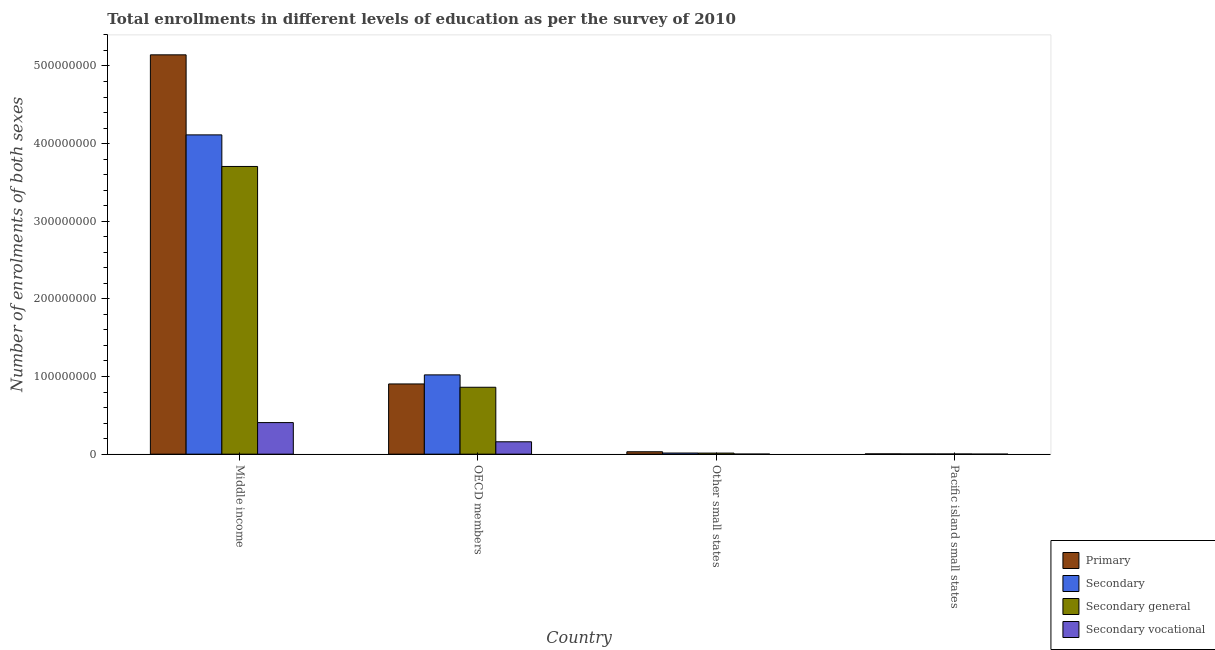How many different coloured bars are there?
Make the answer very short. 4. Are the number of bars on each tick of the X-axis equal?
Offer a very short reply. Yes. How many bars are there on the 2nd tick from the left?
Give a very brief answer. 4. What is the number of enrolments in primary education in Pacific island small states?
Provide a short and direct response. 3.53e+05. Across all countries, what is the maximum number of enrolments in secondary vocational education?
Your answer should be compact. 4.07e+07. Across all countries, what is the minimum number of enrolments in secondary vocational education?
Offer a very short reply. 5214.71. In which country was the number of enrolments in secondary vocational education minimum?
Make the answer very short. Pacific island small states. What is the total number of enrolments in primary education in the graph?
Provide a short and direct response. 6.08e+08. What is the difference between the number of enrolments in secondary general education in OECD members and that in Other small states?
Provide a succinct answer. 8.48e+07. What is the difference between the number of enrolments in secondary vocational education in Pacific island small states and the number of enrolments in primary education in Other small states?
Offer a very short reply. -3.08e+06. What is the average number of enrolments in secondary education per country?
Provide a succinct answer. 1.29e+08. What is the difference between the number of enrolments in secondary vocational education and number of enrolments in secondary general education in Other small states?
Offer a terse response. -1.31e+06. What is the ratio of the number of enrolments in secondary vocational education in OECD members to that in Other small states?
Ensure brevity in your answer.  196.79. Is the difference between the number of enrolments in primary education in Middle income and Other small states greater than the difference between the number of enrolments in secondary general education in Middle income and Other small states?
Your answer should be compact. Yes. What is the difference between the highest and the second highest number of enrolments in secondary general education?
Provide a succinct answer. 2.84e+08. What is the difference between the highest and the lowest number of enrolments in secondary vocational education?
Your answer should be very brief. 4.07e+07. In how many countries, is the number of enrolments in secondary education greater than the average number of enrolments in secondary education taken over all countries?
Provide a short and direct response. 1. Is the sum of the number of enrolments in secondary education in OECD members and Other small states greater than the maximum number of enrolments in secondary vocational education across all countries?
Your answer should be very brief. Yes. Is it the case that in every country, the sum of the number of enrolments in secondary vocational education and number of enrolments in primary education is greater than the sum of number of enrolments in secondary general education and number of enrolments in secondary education?
Your response must be concise. No. What does the 3rd bar from the left in OECD members represents?
Make the answer very short. Secondary general. What does the 3rd bar from the right in OECD members represents?
Give a very brief answer. Secondary. How many bars are there?
Offer a terse response. 16. Are all the bars in the graph horizontal?
Provide a short and direct response. No. How many countries are there in the graph?
Your answer should be compact. 4. Are the values on the major ticks of Y-axis written in scientific E-notation?
Give a very brief answer. No. Does the graph contain any zero values?
Offer a terse response. No. Where does the legend appear in the graph?
Provide a short and direct response. Bottom right. How many legend labels are there?
Provide a succinct answer. 4. What is the title of the graph?
Your answer should be very brief. Total enrollments in different levels of education as per the survey of 2010. Does "Water" appear as one of the legend labels in the graph?
Provide a short and direct response. No. What is the label or title of the Y-axis?
Offer a terse response. Number of enrolments of both sexes. What is the Number of enrolments of both sexes in Primary in Middle income?
Make the answer very short. 5.14e+08. What is the Number of enrolments of both sexes in Secondary in Middle income?
Provide a succinct answer. 4.11e+08. What is the Number of enrolments of both sexes in Secondary general in Middle income?
Your response must be concise. 3.71e+08. What is the Number of enrolments of both sexes of Secondary vocational in Middle income?
Provide a short and direct response. 4.07e+07. What is the Number of enrolments of both sexes of Primary in OECD members?
Provide a succinct answer. 9.04e+07. What is the Number of enrolments of both sexes of Secondary in OECD members?
Ensure brevity in your answer.  1.02e+08. What is the Number of enrolments of both sexes of Secondary general in OECD members?
Offer a very short reply. 8.62e+07. What is the Number of enrolments of both sexes in Secondary vocational in OECD members?
Offer a very short reply. 1.59e+07. What is the Number of enrolments of both sexes in Primary in Other small states?
Your response must be concise. 3.09e+06. What is the Number of enrolments of both sexes in Secondary in Other small states?
Your response must be concise. 1.47e+06. What is the Number of enrolments of both sexes of Secondary general in Other small states?
Offer a very short reply. 1.39e+06. What is the Number of enrolments of both sexes in Secondary vocational in Other small states?
Provide a succinct answer. 8.10e+04. What is the Number of enrolments of both sexes in Primary in Pacific island small states?
Keep it short and to the point. 3.53e+05. What is the Number of enrolments of both sexes of Secondary in Pacific island small states?
Give a very brief answer. 2.35e+05. What is the Number of enrolments of both sexes of Secondary general in Pacific island small states?
Ensure brevity in your answer.  2.30e+05. What is the Number of enrolments of both sexes in Secondary vocational in Pacific island small states?
Provide a succinct answer. 5214.71. Across all countries, what is the maximum Number of enrolments of both sexes in Primary?
Your response must be concise. 5.14e+08. Across all countries, what is the maximum Number of enrolments of both sexes of Secondary?
Provide a short and direct response. 4.11e+08. Across all countries, what is the maximum Number of enrolments of both sexes in Secondary general?
Ensure brevity in your answer.  3.71e+08. Across all countries, what is the maximum Number of enrolments of both sexes in Secondary vocational?
Your response must be concise. 4.07e+07. Across all countries, what is the minimum Number of enrolments of both sexes of Primary?
Ensure brevity in your answer.  3.53e+05. Across all countries, what is the minimum Number of enrolments of both sexes of Secondary?
Provide a short and direct response. 2.35e+05. Across all countries, what is the minimum Number of enrolments of both sexes of Secondary general?
Ensure brevity in your answer.  2.30e+05. Across all countries, what is the minimum Number of enrolments of both sexes of Secondary vocational?
Provide a succinct answer. 5214.71. What is the total Number of enrolments of both sexes in Primary in the graph?
Ensure brevity in your answer.  6.08e+08. What is the total Number of enrolments of both sexes in Secondary in the graph?
Keep it short and to the point. 5.15e+08. What is the total Number of enrolments of both sexes of Secondary general in the graph?
Offer a very short reply. 4.58e+08. What is the total Number of enrolments of both sexes in Secondary vocational in the graph?
Offer a very short reply. 5.67e+07. What is the difference between the Number of enrolments of both sexes in Primary in Middle income and that in OECD members?
Offer a terse response. 4.24e+08. What is the difference between the Number of enrolments of both sexes of Secondary in Middle income and that in OECD members?
Offer a terse response. 3.09e+08. What is the difference between the Number of enrolments of both sexes in Secondary general in Middle income and that in OECD members?
Your answer should be compact. 2.84e+08. What is the difference between the Number of enrolments of both sexes of Secondary vocational in Middle income and that in OECD members?
Give a very brief answer. 2.47e+07. What is the difference between the Number of enrolments of both sexes in Primary in Middle income and that in Other small states?
Offer a terse response. 5.11e+08. What is the difference between the Number of enrolments of both sexes in Secondary in Middle income and that in Other small states?
Your answer should be compact. 4.10e+08. What is the difference between the Number of enrolments of both sexes in Secondary general in Middle income and that in Other small states?
Offer a very short reply. 3.69e+08. What is the difference between the Number of enrolments of both sexes of Secondary vocational in Middle income and that in Other small states?
Your response must be concise. 4.06e+07. What is the difference between the Number of enrolments of both sexes of Primary in Middle income and that in Pacific island small states?
Your response must be concise. 5.14e+08. What is the difference between the Number of enrolments of both sexes in Secondary in Middle income and that in Pacific island small states?
Offer a terse response. 4.11e+08. What is the difference between the Number of enrolments of both sexes in Secondary general in Middle income and that in Pacific island small states?
Give a very brief answer. 3.70e+08. What is the difference between the Number of enrolments of both sexes of Secondary vocational in Middle income and that in Pacific island small states?
Keep it short and to the point. 4.07e+07. What is the difference between the Number of enrolments of both sexes of Primary in OECD members and that in Other small states?
Your response must be concise. 8.74e+07. What is the difference between the Number of enrolments of both sexes of Secondary in OECD members and that in Other small states?
Ensure brevity in your answer.  1.01e+08. What is the difference between the Number of enrolments of both sexes of Secondary general in OECD members and that in Other small states?
Your answer should be very brief. 8.48e+07. What is the difference between the Number of enrolments of both sexes of Secondary vocational in OECD members and that in Other small states?
Make the answer very short. 1.59e+07. What is the difference between the Number of enrolments of both sexes of Primary in OECD members and that in Pacific island small states?
Make the answer very short. 9.01e+07. What is the difference between the Number of enrolments of both sexes of Secondary in OECD members and that in Pacific island small states?
Provide a succinct answer. 1.02e+08. What is the difference between the Number of enrolments of both sexes of Secondary general in OECD members and that in Pacific island small states?
Ensure brevity in your answer.  8.59e+07. What is the difference between the Number of enrolments of both sexes of Secondary vocational in OECD members and that in Pacific island small states?
Keep it short and to the point. 1.59e+07. What is the difference between the Number of enrolments of both sexes in Primary in Other small states and that in Pacific island small states?
Ensure brevity in your answer.  2.74e+06. What is the difference between the Number of enrolments of both sexes in Secondary in Other small states and that in Pacific island small states?
Your answer should be compact. 1.23e+06. What is the difference between the Number of enrolments of both sexes of Secondary general in Other small states and that in Pacific island small states?
Your answer should be very brief. 1.16e+06. What is the difference between the Number of enrolments of both sexes in Secondary vocational in Other small states and that in Pacific island small states?
Ensure brevity in your answer.  7.58e+04. What is the difference between the Number of enrolments of both sexes of Primary in Middle income and the Number of enrolments of both sexes of Secondary in OECD members?
Your answer should be compact. 4.12e+08. What is the difference between the Number of enrolments of both sexes of Primary in Middle income and the Number of enrolments of both sexes of Secondary general in OECD members?
Your answer should be compact. 4.28e+08. What is the difference between the Number of enrolments of both sexes in Primary in Middle income and the Number of enrolments of both sexes in Secondary vocational in OECD members?
Give a very brief answer. 4.98e+08. What is the difference between the Number of enrolments of both sexes of Secondary in Middle income and the Number of enrolments of both sexes of Secondary general in OECD members?
Your response must be concise. 3.25e+08. What is the difference between the Number of enrolments of both sexes of Secondary in Middle income and the Number of enrolments of both sexes of Secondary vocational in OECD members?
Offer a very short reply. 3.95e+08. What is the difference between the Number of enrolments of both sexes of Secondary general in Middle income and the Number of enrolments of both sexes of Secondary vocational in OECD members?
Your response must be concise. 3.55e+08. What is the difference between the Number of enrolments of both sexes of Primary in Middle income and the Number of enrolments of both sexes of Secondary in Other small states?
Your answer should be very brief. 5.13e+08. What is the difference between the Number of enrolments of both sexes in Primary in Middle income and the Number of enrolments of both sexes in Secondary general in Other small states?
Provide a succinct answer. 5.13e+08. What is the difference between the Number of enrolments of both sexes in Primary in Middle income and the Number of enrolments of both sexes in Secondary vocational in Other small states?
Make the answer very short. 5.14e+08. What is the difference between the Number of enrolments of both sexes of Secondary in Middle income and the Number of enrolments of both sexes of Secondary general in Other small states?
Your response must be concise. 4.10e+08. What is the difference between the Number of enrolments of both sexes of Secondary in Middle income and the Number of enrolments of both sexes of Secondary vocational in Other small states?
Offer a very short reply. 4.11e+08. What is the difference between the Number of enrolments of both sexes of Secondary general in Middle income and the Number of enrolments of both sexes of Secondary vocational in Other small states?
Give a very brief answer. 3.70e+08. What is the difference between the Number of enrolments of both sexes in Primary in Middle income and the Number of enrolments of both sexes in Secondary in Pacific island small states?
Your response must be concise. 5.14e+08. What is the difference between the Number of enrolments of both sexes of Primary in Middle income and the Number of enrolments of both sexes of Secondary general in Pacific island small states?
Ensure brevity in your answer.  5.14e+08. What is the difference between the Number of enrolments of both sexes in Primary in Middle income and the Number of enrolments of both sexes in Secondary vocational in Pacific island small states?
Give a very brief answer. 5.14e+08. What is the difference between the Number of enrolments of both sexes in Secondary in Middle income and the Number of enrolments of both sexes in Secondary general in Pacific island small states?
Offer a terse response. 4.11e+08. What is the difference between the Number of enrolments of both sexes of Secondary in Middle income and the Number of enrolments of both sexes of Secondary vocational in Pacific island small states?
Your answer should be very brief. 4.11e+08. What is the difference between the Number of enrolments of both sexes of Secondary general in Middle income and the Number of enrolments of both sexes of Secondary vocational in Pacific island small states?
Offer a terse response. 3.71e+08. What is the difference between the Number of enrolments of both sexes in Primary in OECD members and the Number of enrolments of both sexes in Secondary in Other small states?
Your answer should be very brief. 8.90e+07. What is the difference between the Number of enrolments of both sexes of Primary in OECD members and the Number of enrolments of both sexes of Secondary general in Other small states?
Offer a terse response. 8.91e+07. What is the difference between the Number of enrolments of both sexes of Primary in OECD members and the Number of enrolments of both sexes of Secondary vocational in Other small states?
Provide a short and direct response. 9.04e+07. What is the difference between the Number of enrolments of both sexes in Secondary in OECD members and the Number of enrolments of both sexes in Secondary general in Other small states?
Provide a short and direct response. 1.01e+08. What is the difference between the Number of enrolments of both sexes of Secondary in OECD members and the Number of enrolments of both sexes of Secondary vocational in Other small states?
Provide a succinct answer. 1.02e+08. What is the difference between the Number of enrolments of both sexes of Secondary general in OECD members and the Number of enrolments of both sexes of Secondary vocational in Other small states?
Ensure brevity in your answer.  8.61e+07. What is the difference between the Number of enrolments of both sexes of Primary in OECD members and the Number of enrolments of both sexes of Secondary in Pacific island small states?
Provide a short and direct response. 9.02e+07. What is the difference between the Number of enrolments of both sexes of Primary in OECD members and the Number of enrolments of both sexes of Secondary general in Pacific island small states?
Make the answer very short. 9.02e+07. What is the difference between the Number of enrolments of both sexes of Primary in OECD members and the Number of enrolments of both sexes of Secondary vocational in Pacific island small states?
Provide a short and direct response. 9.04e+07. What is the difference between the Number of enrolments of both sexes of Secondary in OECD members and the Number of enrolments of both sexes of Secondary general in Pacific island small states?
Make the answer very short. 1.02e+08. What is the difference between the Number of enrolments of both sexes in Secondary in OECD members and the Number of enrolments of both sexes in Secondary vocational in Pacific island small states?
Offer a very short reply. 1.02e+08. What is the difference between the Number of enrolments of both sexes of Secondary general in OECD members and the Number of enrolments of both sexes of Secondary vocational in Pacific island small states?
Offer a very short reply. 8.62e+07. What is the difference between the Number of enrolments of both sexes of Primary in Other small states and the Number of enrolments of both sexes of Secondary in Pacific island small states?
Ensure brevity in your answer.  2.85e+06. What is the difference between the Number of enrolments of both sexes in Primary in Other small states and the Number of enrolments of both sexes in Secondary general in Pacific island small states?
Offer a terse response. 2.86e+06. What is the difference between the Number of enrolments of both sexes in Primary in Other small states and the Number of enrolments of both sexes in Secondary vocational in Pacific island small states?
Give a very brief answer. 3.08e+06. What is the difference between the Number of enrolments of both sexes in Secondary in Other small states and the Number of enrolments of both sexes in Secondary general in Pacific island small states?
Provide a short and direct response. 1.24e+06. What is the difference between the Number of enrolments of both sexes of Secondary in Other small states and the Number of enrolments of both sexes of Secondary vocational in Pacific island small states?
Give a very brief answer. 1.46e+06. What is the difference between the Number of enrolments of both sexes of Secondary general in Other small states and the Number of enrolments of both sexes of Secondary vocational in Pacific island small states?
Provide a short and direct response. 1.38e+06. What is the average Number of enrolments of both sexes in Primary per country?
Make the answer very short. 1.52e+08. What is the average Number of enrolments of both sexes of Secondary per country?
Give a very brief answer. 1.29e+08. What is the average Number of enrolments of both sexes of Secondary general per country?
Provide a succinct answer. 1.15e+08. What is the average Number of enrolments of both sexes of Secondary vocational per country?
Give a very brief answer. 1.42e+07. What is the difference between the Number of enrolments of both sexes in Primary and Number of enrolments of both sexes in Secondary in Middle income?
Your answer should be very brief. 1.03e+08. What is the difference between the Number of enrolments of both sexes of Primary and Number of enrolments of both sexes of Secondary general in Middle income?
Offer a terse response. 1.44e+08. What is the difference between the Number of enrolments of both sexes in Primary and Number of enrolments of both sexes in Secondary vocational in Middle income?
Provide a short and direct response. 4.74e+08. What is the difference between the Number of enrolments of both sexes of Secondary and Number of enrolments of both sexes of Secondary general in Middle income?
Offer a terse response. 4.07e+07. What is the difference between the Number of enrolments of both sexes in Secondary and Number of enrolments of both sexes in Secondary vocational in Middle income?
Keep it short and to the point. 3.71e+08. What is the difference between the Number of enrolments of both sexes of Secondary general and Number of enrolments of both sexes of Secondary vocational in Middle income?
Your answer should be compact. 3.30e+08. What is the difference between the Number of enrolments of both sexes of Primary and Number of enrolments of both sexes of Secondary in OECD members?
Ensure brevity in your answer.  -1.17e+07. What is the difference between the Number of enrolments of both sexes of Primary and Number of enrolments of both sexes of Secondary general in OECD members?
Offer a terse response. 4.26e+06. What is the difference between the Number of enrolments of both sexes in Primary and Number of enrolments of both sexes in Secondary vocational in OECD members?
Provide a short and direct response. 7.45e+07. What is the difference between the Number of enrolments of both sexes of Secondary and Number of enrolments of both sexes of Secondary general in OECD members?
Ensure brevity in your answer.  1.59e+07. What is the difference between the Number of enrolments of both sexes in Secondary and Number of enrolments of both sexes in Secondary vocational in OECD members?
Your answer should be very brief. 8.62e+07. What is the difference between the Number of enrolments of both sexes of Secondary general and Number of enrolments of both sexes of Secondary vocational in OECD members?
Offer a very short reply. 7.02e+07. What is the difference between the Number of enrolments of both sexes of Primary and Number of enrolments of both sexes of Secondary in Other small states?
Your answer should be very brief. 1.62e+06. What is the difference between the Number of enrolments of both sexes in Primary and Number of enrolments of both sexes in Secondary general in Other small states?
Your answer should be compact. 1.70e+06. What is the difference between the Number of enrolments of both sexes in Primary and Number of enrolments of both sexes in Secondary vocational in Other small states?
Offer a very short reply. 3.01e+06. What is the difference between the Number of enrolments of both sexes in Secondary and Number of enrolments of both sexes in Secondary general in Other small states?
Offer a terse response. 8.10e+04. What is the difference between the Number of enrolments of both sexes in Secondary and Number of enrolments of both sexes in Secondary vocational in Other small states?
Make the answer very short. 1.39e+06. What is the difference between the Number of enrolments of both sexes of Secondary general and Number of enrolments of both sexes of Secondary vocational in Other small states?
Offer a very short reply. 1.31e+06. What is the difference between the Number of enrolments of both sexes of Primary and Number of enrolments of both sexes of Secondary in Pacific island small states?
Make the answer very short. 1.18e+05. What is the difference between the Number of enrolments of both sexes of Primary and Number of enrolments of both sexes of Secondary general in Pacific island small states?
Provide a succinct answer. 1.23e+05. What is the difference between the Number of enrolments of both sexes in Primary and Number of enrolments of both sexes in Secondary vocational in Pacific island small states?
Give a very brief answer. 3.48e+05. What is the difference between the Number of enrolments of both sexes in Secondary and Number of enrolments of both sexes in Secondary general in Pacific island small states?
Your answer should be very brief. 5214.7. What is the difference between the Number of enrolments of both sexes in Secondary and Number of enrolments of both sexes in Secondary vocational in Pacific island small states?
Provide a short and direct response. 2.30e+05. What is the difference between the Number of enrolments of both sexes in Secondary general and Number of enrolments of both sexes in Secondary vocational in Pacific island small states?
Keep it short and to the point. 2.25e+05. What is the ratio of the Number of enrolments of both sexes of Primary in Middle income to that in OECD members?
Provide a short and direct response. 5.69. What is the ratio of the Number of enrolments of both sexes of Secondary in Middle income to that in OECD members?
Provide a short and direct response. 4.03. What is the ratio of the Number of enrolments of both sexes of Secondary general in Middle income to that in OECD members?
Keep it short and to the point. 4.3. What is the ratio of the Number of enrolments of both sexes in Secondary vocational in Middle income to that in OECD members?
Provide a short and direct response. 2.55. What is the ratio of the Number of enrolments of both sexes of Primary in Middle income to that in Other small states?
Give a very brief answer. 166.48. What is the ratio of the Number of enrolments of both sexes of Secondary in Middle income to that in Other small states?
Provide a succinct answer. 280.15. What is the ratio of the Number of enrolments of both sexes of Secondary general in Middle income to that in Other small states?
Your response must be concise. 267.19. What is the ratio of the Number of enrolments of both sexes in Secondary vocational in Middle income to that in Other small states?
Give a very brief answer. 502.23. What is the ratio of the Number of enrolments of both sexes of Primary in Middle income to that in Pacific island small states?
Provide a succinct answer. 1457.9. What is the ratio of the Number of enrolments of both sexes in Secondary in Middle income to that in Pacific island small states?
Provide a succinct answer. 1748.15. What is the ratio of the Number of enrolments of both sexes of Secondary general in Middle income to that in Pacific island small states?
Make the answer very short. 1610.95. What is the ratio of the Number of enrolments of both sexes of Secondary vocational in Middle income to that in Pacific island small states?
Ensure brevity in your answer.  7800.24. What is the ratio of the Number of enrolments of both sexes in Primary in OECD members to that in Other small states?
Ensure brevity in your answer.  29.27. What is the ratio of the Number of enrolments of both sexes in Secondary in OECD members to that in Other small states?
Ensure brevity in your answer.  69.57. What is the ratio of the Number of enrolments of both sexes in Secondary general in OECD members to that in Other small states?
Your answer should be very brief. 62.14. What is the ratio of the Number of enrolments of both sexes in Secondary vocational in OECD members to that in Other small states?
Your answer should be very brief. 196.79. What is the ratio of the Number of enrolments of both sexes in Primary in OECD members to that in Pacific island small states?
Your answer should be compact. 256.36. What is the ratio of the Number of enrolments of both sexes in Secondary in OECD members to that in Pacific island small states?
Offer a terse response. 434.1. What is the ratio of the Number of enrolments of both sexes of Secondary general in OECD members to that in Pacific island small states?
Keep it short and to the point. 374.65. What is the ratio of the Number of enrolments of both sexes in Secondary vocational in OECD members to that in Pacific island small states?
Offer a terse response. 3056.38. What is the ratio of the Number of enrolments of both sexes in Primary in Other small states to that in Pacific island small states?
Your response must be concise. 8.76. What is the ratio of the Number of enrolments of both sexes of Secondary in Other small states to that in Pacific island small states?
Offer a terse response. 6.24. What is the ratio of the Number of enrolments of both sexes in Secondary general in Other small states to that in Pacific island small states?
Give a very brief answer. 6.03. What is the ratio of the Number of enrolments of both sexes of Secondary vocational in Other small states to that in Pacific island small states?
Provide a short and direct response. 15.53. What is the difference between the highest and the second highest Number of enrolments of both sexes in Primary?
Make the answer very short. 4.24e+08. What is the difference between the highest and the second highest Number of enrolments of both sexes of Secondary?
Ensure brevity in your answer.  3.09e+08. What is the difference between the highest and the second highest Number of enrolments of both sexes of Secondary general?
Provide a short and direct response. 2.84e+08. What is the difference between the highest and the second highest Number of enrolments of both sexes of Secondary vocational?
Your response must be concise. 2.47e+07. What is the difference between the highest and the lowest Number of enrolments of both sexes of Primary?
Ensure brevity in your answer.  5.14e+08. What is the difference between the highest and the lowest Number of enrolments of both sexes of Secondary?
Your answer should be compact. 4.11e+08. What is the difference between the highest and the lowest Number of enrolments of both sexes in Secondary general?
Ensure brevity in your answer.  3.70e+08. What is the difference between the highest and the lowest Number of enrolments of both sexes of Secondary vocational?
Provide a short and direct response. 4.07e+07. 